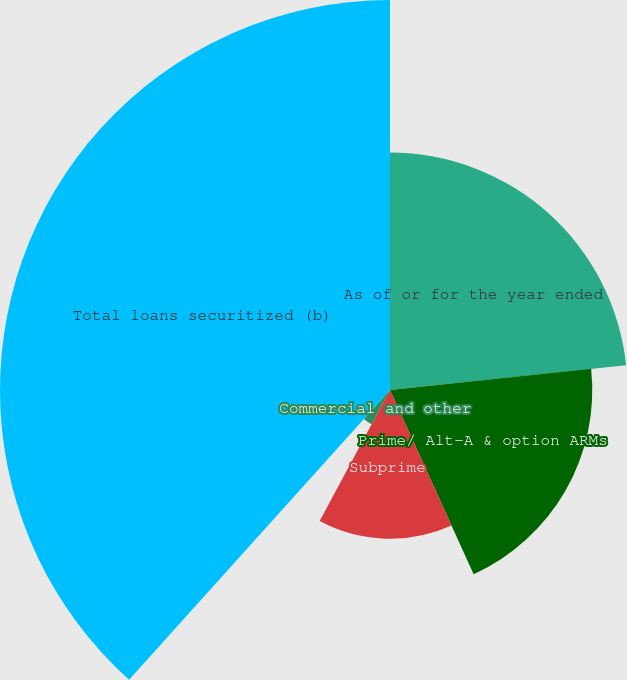Convert chart to OTSL. <chart><loc_0><loc_0><loc_500><loc_500><pie_chart><fcel>As of or for the year ended<fcel>Prime/ Alt-A & option ARMs<fcel>Subprime<fcel>Commercial and other<fcel>Total loans securitized (b)<nl><fcel>23.33%<fcel>19.88%<fcel>14.62%<fcel>3.83%<fcel>38.33%<nl></chart> 